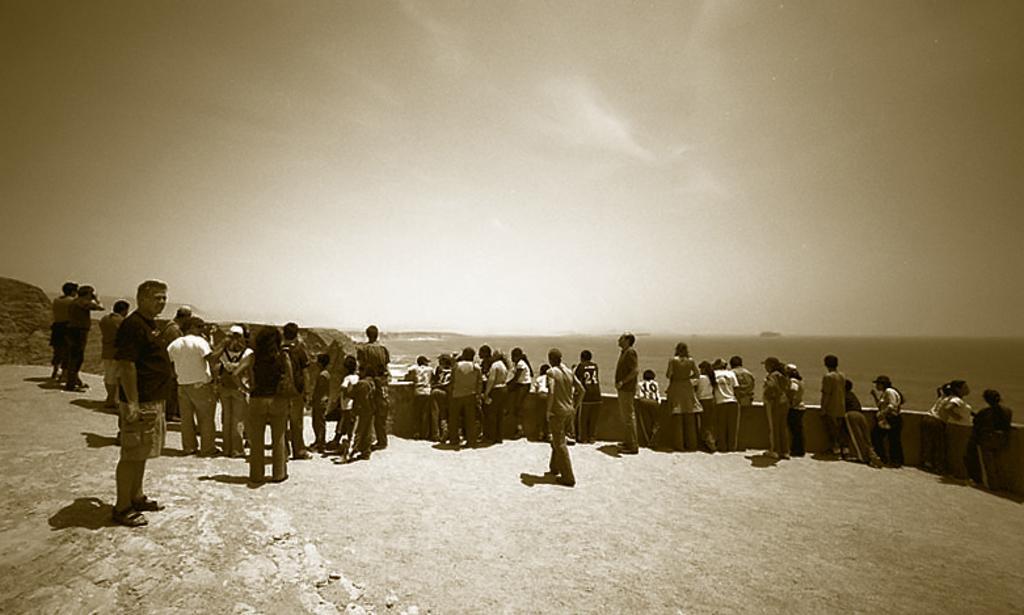Please provide a concise description of this image. In this picture we can see some people standing and looking at something, there is the sky at the top of the picture, it is a black and white image. 